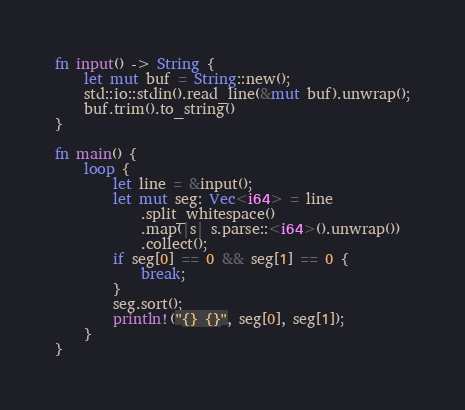<code> <loc_0><loc_0><loc_500><loc_500><_Rust_>fn input() -> String {
    let mut buf = String::new();
    std::io::stdin().read_line(&mut buf).unwrap();
    buf.trim().to_string()
}

fn main() {
    loop {
        let line = &input();
        let mut seg: Vec<i64> = line
            .split_whitespace()
            .map(|s| s.parse::<i64>().unwrap())
            .collect();
        if seg[0] == 0 && seg[1] == 0 {
            break;
        }
        seg.sort();
        println!("{} {}", seg[0], seg[1]);
    }
}
</code> 